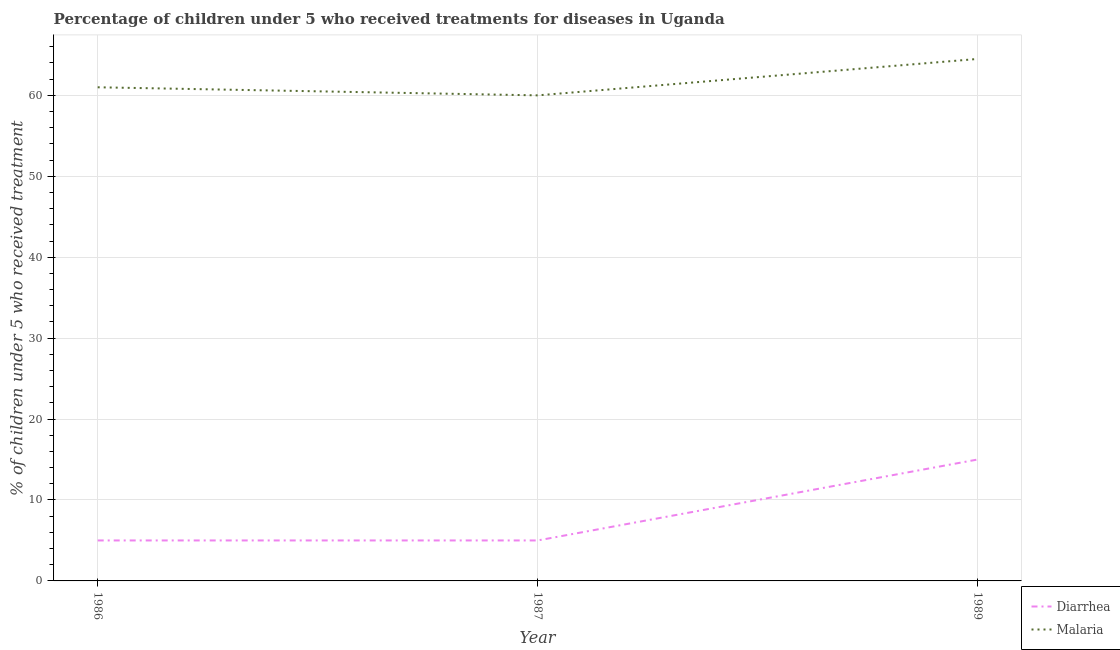What is the percentage of children who received treatment for diarrhoea in 1987?
Keep it short and to the point. 5. Across all years, what is the maximum percentage of children who received treatment for malaria?
Make the answer very short. 64.5. Across all years, what is the minimum percentage of children who received treatment for diarrhoea?
Keep it short and to the point. 5. In which year was the percentage of children who received treatment for malaria minimum?
Your answer should be very brief. 1987. What is the total percentage of children who received treatment for malaria in the graph?
Give a very brief answer. 185.5. What is the difference between the percentage of children who received treatment for malaria in 1986 and that in 1987?
Offer a terse response. 1. What is the difference between the percentage of children who received treatment for diarrhoea in 1986 and the percentage of children who received treatment for malaria in 1987?
Keep it short and to the point. -55. What is the average percentage of children who received treatment for diarrhoea per year?
Your response must be concise. 8.33. In the year 1986, what is the difference between the percentage of children who received treatment for malaria and percentage of children who received treatment for diarrhoea?
Offer a very short reply. 56. What is the ratio of the percentage of children who received treatment for diarrhoea in 1986 to that in 1989?
Provide a succinct answer. 0.33. Is the percentage of children who received treatment for diarrhoea in 1987 less than that in 1989?
Keep it short and to the point. Yes. Is the difference between the percentage of children who received treatment for diarrhoea in 1986 and 1989 greater than the difference between the percentage of children who received treatment for malaria in 1986 and 1989?
Provide a succinct answer. No. What is the difference between the highest and the second highest percentage of children who received treatment for malaria?
Offer a very short reply. 3.5. What is the difference between the highest and the lowest percentage of children who received treatment for diarrhoea?
Provide a succinct answer. 10. In how many years, is the percentage of children who received treatment for diarrhoea greater than the average percentage of children who received treatment for diarrhoea taken over all years?
Offer a terse response. 1. How many lines are there?
Your answer should be very brief. 2. How many years are there in the graph?
Make the answer very short. 3. What is the difference between two consecutive major ticks on the Y-axis?
Keep it short and to the point. 10. Does the graph contain grids?
Offer a very short reply. Yes. How many legend labels are there?
Offer a very short reply. 2. What is the title of the graph?
Your response must be concise. Percentage of children under 5 who received treatments for diseases in Uganda. What is the label or title of the X-axis?
Provide a short and direct response. Year. What is the label or title of the Y-axis?
Provide a short and direct response. % of children under 5 who received treatment. What is the % of children under 5 who received treatment in Diarrhea in 1986?
Offer a very short reply. 5. What is the % of children under 5 who received treatment of Malaria in 1986?
Your answer should be very brief. 61. What is the % of children under 5 who received treatment of Diarrhea in 1987?
Provide a succinct answer. 5. What is the % of children under 5 who received treatment of Malaria in 1987?
Give a very brief answer. 60. What is the % of children under 5 who received treatment in Malaria in 1989?
Your answer should be very brief. 64.5. Across all years, what is the maximum % of children under 5 who received treatment of Malaria?
Keep it short and to the point. 64.5. Across all years, what is the minimum % of children under 5 who received treatment in Diarrhea?
Ensure brevity in your answer.  5. Across all years, what is the minimum % of children under 5 who received treatment of Malaria?
Ensure brevity in your answer.  60. What is the total % of children under 5 who received treatment in Malaria in the graph?
Your answer should be compact. 185.5. What is the difference between the % of children under 5 who received treatment of Diarrhea in 1986 and that in 1987?
Offer a very short reply. 0. What is the difference between the % of children under 5 who received treatment of Malaria in 1986 and that in 1987?
Keep it short and to the point. 1. What is the difference between the % of children under 5 who received treatment of Diarrhea in 1986 and that in 1989?
Make the answer very short. -10. What is the difference between the % of children under 5 who received treatment of Diarrhea in 1987 and that in 1989?
Offer a very short reply. -10. What is the difference between the % of children under 5 who received treatment of Diarrhea in 1986 and the % of children under 5 who received treatment of Malaria in 1987?
Provide a succinct answer. -55. What is the difference between the % of children under 5 who received treatment in Diarrhea in 1986 and the % of children under 5 who received treatment in Malaria in 1989?
Your response must be concise. -59.5. What is the difference between the % of children under 5 who received treatment of Diarrhea in 1987 and the % of children under 5 who received treatment of Malaria in 1989?
Your answer should be compact. -59.5. What is the average % of children under 5 who received treatment in Diarrhea per year?
Give a very brief answer. 8.33. What is the average % of children under 5 who received treatment in Malaria per year?
Make the answer very short. 61.83. In the year 1986, what is the difference between the % of children under 5 who received treatment in Diarrhea and % of children under 5 who received treatment in Malaria?
Provide a succinct answer. -56. In the year 1987, what is the difference between the % of children under 5 who received treatment in Diarrhea and % of children under 5 who received treatment in Malaria?
Make the answer very short. -55. In the year 1989, what is the difference between the % of children under 5 who received treatment in Diarrhea and % of children under 5 who received treatment in Malaria?
Provide a succinct answer. -49.5. What is the ratio of the % of children under 5 who received treatment of Malaria in 1986 to that in 1987?
Your answer should be very brief. 1.02. What is the ratio of the % of children under 5 who received treatment in Malaria in 1986 to that in 1989?
Give a very brief answer. 0.95. What is the ratio of the % of children under 5 who received treatment in Diarrhea in 1987 to that in 1989?
Your answer should be very brief. 0.33. What is the ratio of the % of children under 5 who received treatment of Malaria in 1987 to that in 1989?
Provide a succinct answer. 0.93. What is the difference between the highest and the lowest % of children under 5 who received treatment of Malaria?
Your answer should be very brief. 4.5. 